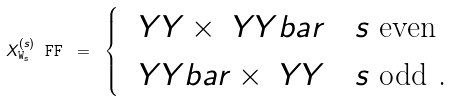<formula> <loc_0><loc_0><loc_500><loc_500>X ^ { ( s ) } \tt _ { W _ { s } } \ F F \ = \ \begin{cases} \ \ Y Y \times \ Y Y b a r & \text {$s$ even } \\ \ \ Y Y b a r \times \ Y Y & \text {$s$ odd .} \end{cases}</formula> 